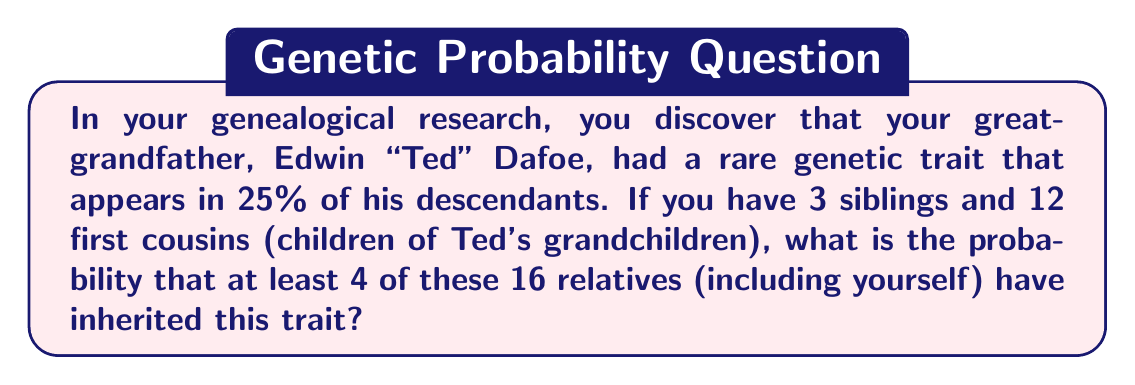Can you answer this question? Let's approach this step-by-step:

1) We need to use the binomial probability distribution to solve this problem.

2) We have:
   - $n = 16$ (total number of relatives including yourself)
   - $p = 0.25$ (probability of having the trait)
   - We want the probability of 4 or more relatives having the trait

3) The probability of at least 4 relatives having the trait is equal to 1 minus the probability of 0, 1, 2, or 3 relatives having the trait.

4) We can calculate this using the binomial probability formula:

   $P(X \geq 4) = 1 - [P(X=0) + P(X=1) + P(X=2) + P(X=3)]$

   Where $P(X=k) = \binom{n}{k} p^k (1-p)^{n-k}$

5) Let's calculate each term:

   $P(X=0) = \binom{16}{0} (0.25)^0 (0.75)^{16} = 0.0100$
   
   $P(X=1) = \binom{16}{1} (0.25)^1 (0.75)^{15} = 0.0535$
   
   $P(X=2) = \binom{16}{2} (0.25)^2 (0.75)^{14} = 0.1336$
   
   $P(X=3) = \binom{16}{3} (0.25)^3 (0.75)^{13} = 0.2003$

6) Now, we can sum these probabilities and subtract from 1:

   $P(X \geq 4) = 1 - (0.0100 + 0.0535 + 0.1336 + 0.2003)$
                $= 1 - 0.3974$
                $= 0.6026$

7) Therefore, the probability that at least 4 of the 16 relatives have inherited the trait is approximately 0.6026 or 60.26%.
Answer: 0.6026 or 60.26% 